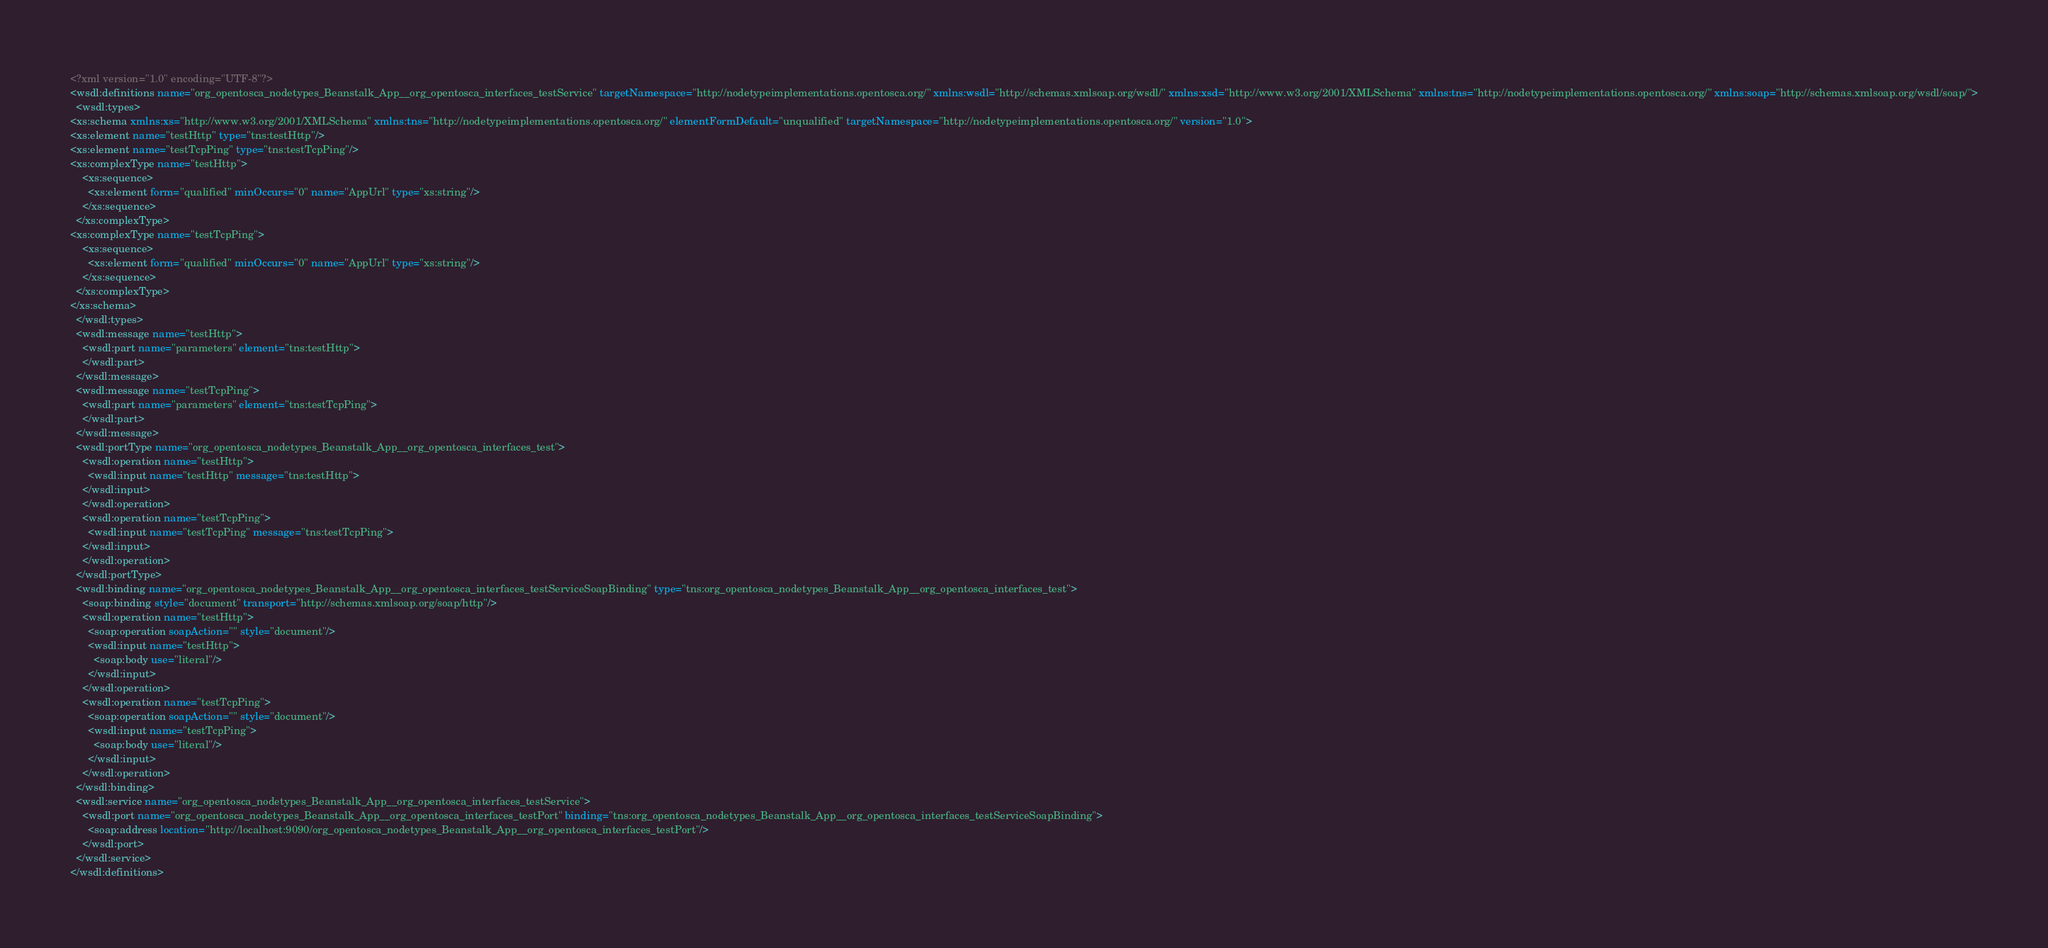Convert code to text. <code><loc_0><loc_0><loc_500><loc_500><_XML_><?xml version="1.0" encoding="UTF-8"?>
<wsdl:definitions name="org_opentosca_nodetypes_Beanstalk_App__org_opentosca_interfaces_testService" targetNamespace="http://nodetypeimplementations.opentosca.org/" xmlns:wsdl="http://schemas.xmlsoap.org/wsdl/" xmlns:xsd="http://www.w3.org/2001/XMLSchema" xmlns:tns="http://nodetypeimplementations.opentosca.org/" xmlns:soap="http://schemas.xmlsoap.org/wsdl/soap/">
  <wsdl:types>
<xs:schema xmlns:xs="http://www.w3.org/2001/XMLSchema" xmlns:tns="http://nodetypeimplementations.opentosca.org/" elementFormDefault="unqualified" targetNamespace="http://nodetypeimplementations.opentosca.org/" version="1.0">
<xs:element name="testHttp" type="tns:testHttp"/>
<xs:element name="testTcpPing" type="tns:testTcpPing"/>
<xs:complexType name="testHttp">
    <xs:sequence>
      <xs:element form="qualified" minOccurs="0" name="AppUrl" type="xs:string"/>
    </xs:sequence>
  </xs:complexType>
<xs:complexType name="testTcpPing">
    <xs:sequence>
      <xs:element form="qualified" minOccurs="0" name="AppUrl" type="xs:string"/>
    </xs:sequence>
  </xs:complexType>
</xs:schema>
  </wsdl:types>
  <wsdl:message name="testHttp">
    <wsdl:part name="parameters" element="tns:testHttp">
    </wsdl:part>
  </wsdl:message>
  <wsdl:message name="testTcpPing">
    <wsdl:part name="parameters" element="tns:testTcpPing">
    </wsdl:part>
  </wsdl:message>
  <wsdl:portType name="org_opentosca_nodetypes_Beanstalk_App__org_opentosca_interfaces_test">
    <wsdl:operation name="testHttp">
      <wsdl:input name="testHttp" message="tns:testHttp">
    </wsdl:input>
    </wsdl:operation>
    <wsdl:operation name="testTcpPing">
      <wsdl:input name="testTcpPing" message="tns:testTcpPing">
    </wsdl:input>
    </wsdl:operation>
  </wsdl:portType>
  <wsdl:binding name="org_opentosca_nodetypes_Beanstalk_App__org_opentosca_interfaces_testServiceSoapBinding" type="tns:org_opentosca_nodetypes_Beanstalk_App__org_opentosca_interfaces_test">
    <soap:binding style="document" transport="http://schemas.xmlsoap.org/soap/http"/>
    <wsdl:operation name="testHttp">
      <soap:operation soapAction="" style="document"/>
      <wsdl:input name="testHttp">
        <soap:body use="literal"/>
      </wsdl:input>
    </wsdl:operation>
    <wsdl:operation name="testTcpPing">
      <soap:operation soapAction="" style="document"/>
      <wsdl:input name="testTcpPing">
        <soap:body use="literal"/>
      </wsdl:input>
    </wsdl:operation>
  </wsdl:binding>
  <wsdl:service name="org_opentosca_nodetypes_Beanstalk_App__org_opentosca_interfaces_testService">
    <wsdl:port name="org_opentosca_nodetypes_Beanstalk_App__org_opentosca_interfaces_testPort" binding="tns:org_opentosca_nodetypes_Beanstalk_App__org_opentosca_interfaces_testServiceSoapBinding">
      <soap:address location="http://localhost:9090/org_opentosca_nodetypes_Beanstalk_App__org_opentosca_interfaces_testPort"/>
    </wsdl:port>
  </wsdl:service>
</wsdl:definitions>
</code> 